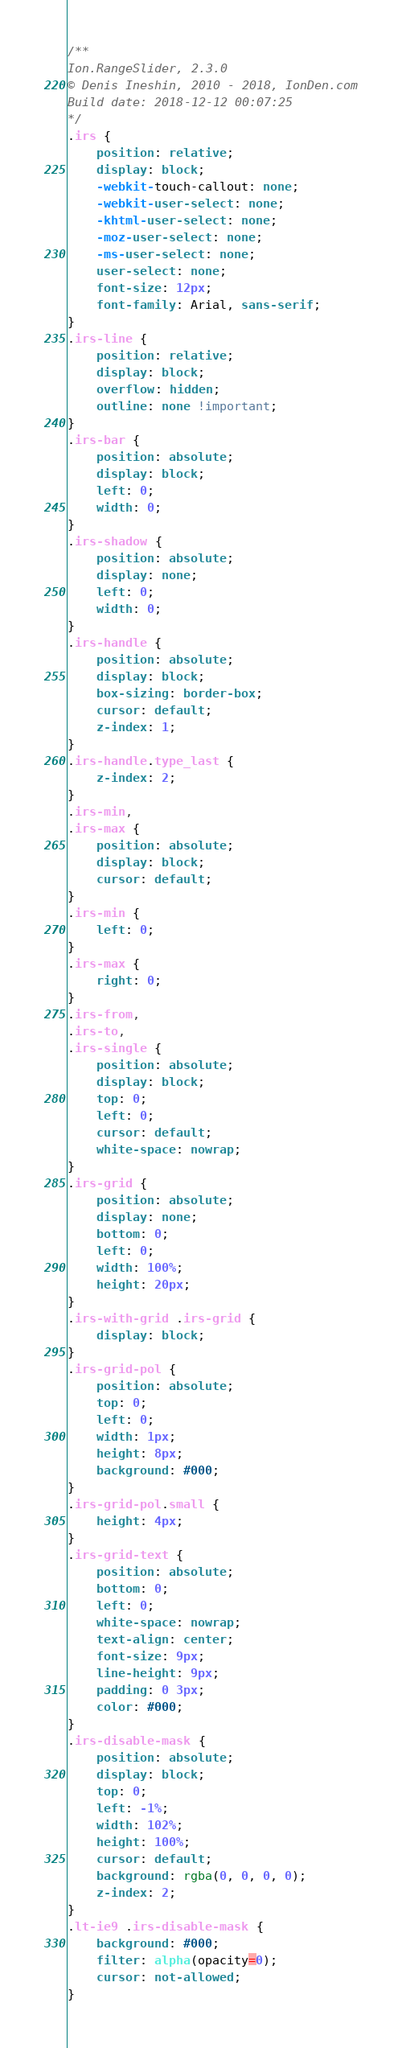Convert code to text. <code><loc_0><loc_0><loc_500><loc_500><_CSS_>/**
Ion.RangeSlider, 2.3.0
© Denis Ineshin, 2010 - 2018, IonDen.com
Build date: 2018-12-12 00:07:25
*/
.irs {
    position: relative;
    display: block;
    -webkit-touch-callout: none;
    -webkit-user-select: none;
    -khtml-user-select: none;
    -moz-user-select: none;
    -ms-user-select: none;
    user-select: none;
    font-size: 12px;
    font-family: Arial, sans-serif;
}
.irs-line {
    position: relative;
    display: block;
    overflow: hidden;
    outline: none !important;
}
.irs-bar {
    position: absolute;
    display: block;
    left: 0;
    width: 0;
}
.irs-shadow {
    position: absolute;
    display: none;
    left: 0;
    width: 0;
}
.irs-handle {
    position: absolute;
    display: block;
    box-sizing: border-box;
    cursor: default;
    z-index: 1;
}
.irs-handle.type_last {
    z-index: 2;
}
.irs-min,
.irs-max {
    position: absolute;
    display: block;
    cursor: default;
}
.irs-min {
    left: 0;
}
.irs-max {
    right: 0;
}
.irs-from,
.irs-to,
.irs-single {
    position: absolute;
    display: block;
    top: 0;
    left: 0;
    cursor: default;
    white-space: nowrap;
}
.irs-grid {
    position: absolute;
    display: none;
    bottom: 0;
    left: 0;
    width: 100%;
    height: 20px;
}
.irs-with-grid .irs-grid {
    display: block;
}
.irs-grid-pol {
    position: absolute;
    top: 0;
    left: 0;
    width: 1px;
    height: 8px;
    background: #000;
}
.irs-grid-pol.small {
    height: 4px;
}
.irs-grid-text {
    position: absolute;
    bottom: 0;
    left: 0;
    white-space: nowrap;
    text-align: center;
    font-size: 9px;
    line-height: 9px;
    padding: 0 3px;
    color: #000;
}
.irs-disable-mask {
    position: absolute;
    display: block;
    top: 0;
    left: -1%;
    width: 102%;
    height: 100%;
    cursor: default;
    background: rgba(0, 0, 0, 0);
    z-index: 2;
}
.lt-ie9 .irs-disable-mask {
    background: #000;
    filter: alpha(opacity=0);
    cursor: not-allowed;
}</code> 